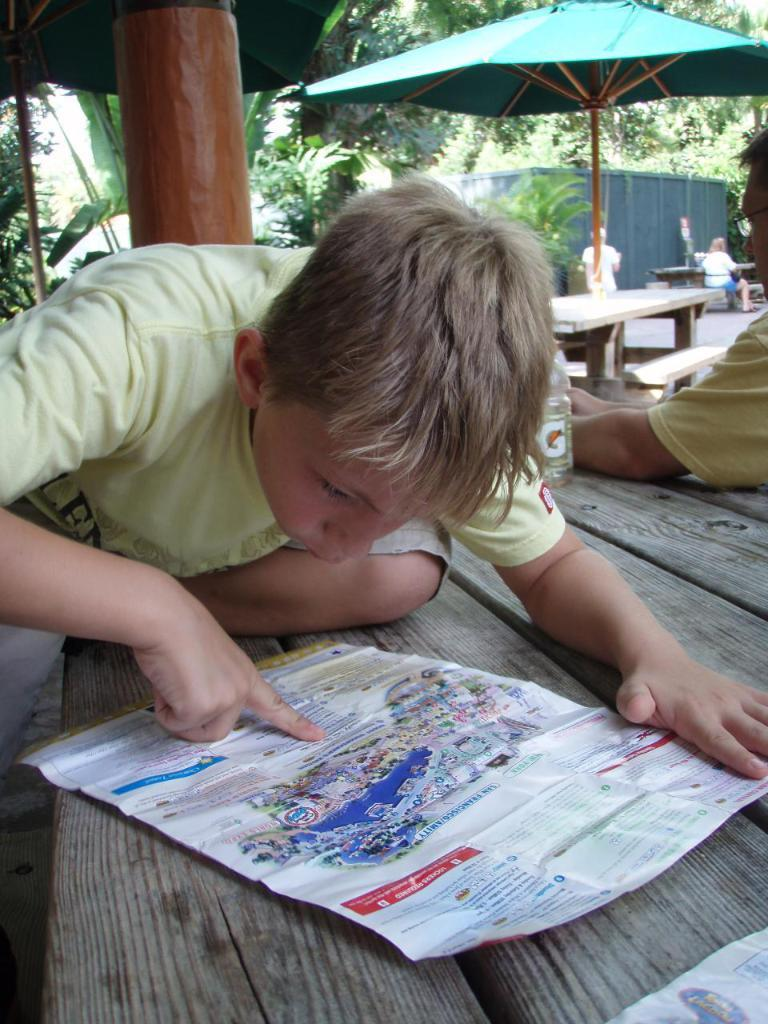Who is the main subject in the image? There is a boy in the image. What is the boy doing in the image? The boy is looking at a paper. What is the setting of the image? There is a table in the image, and there are trees and a wall in the background. Are there any other people in the image? Yes, there is at least one other person in the background of the image. What object is associated with the weather in the image? There is an umbrella in the image. What type of shoes is the minister wearing in the image? There is no minister present in the image, and therefore no shoes to describe. 